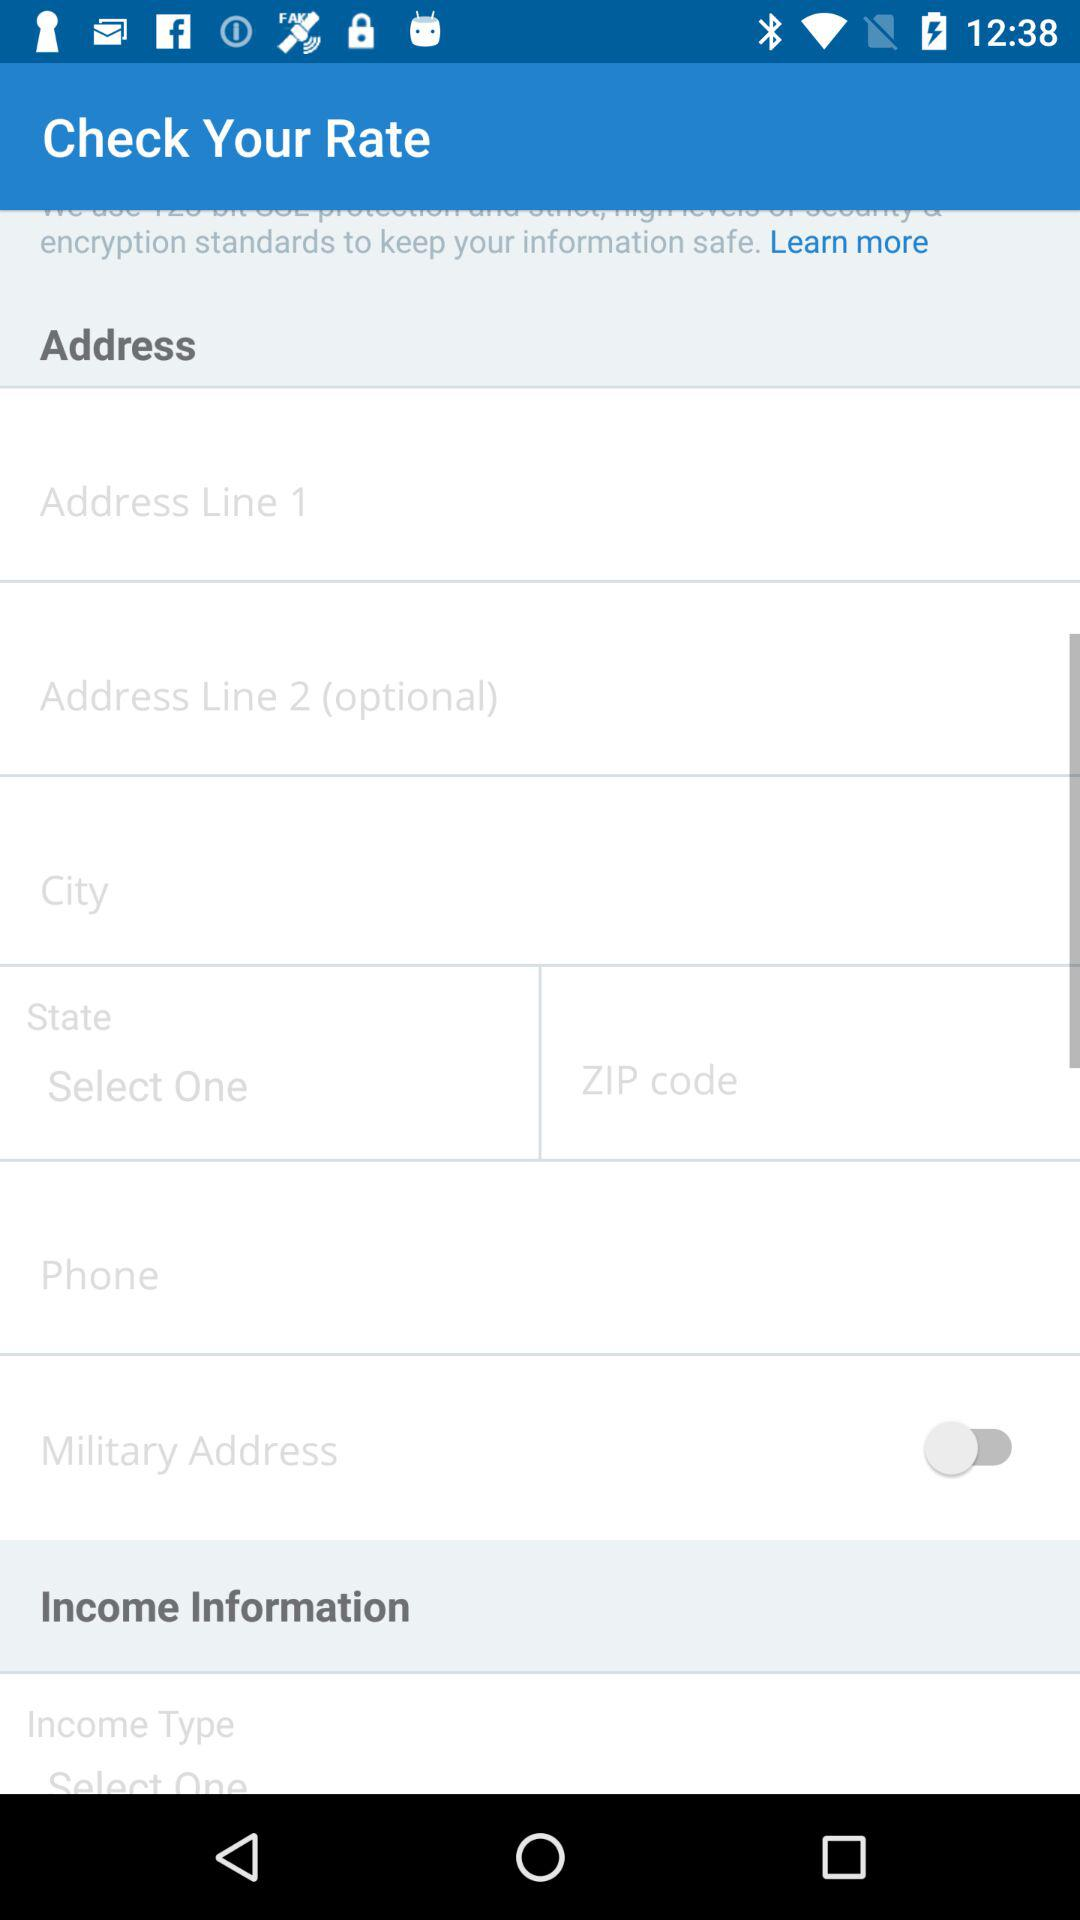How many input fields are there for income information?
Answer the question using a single word or phrase. 1 